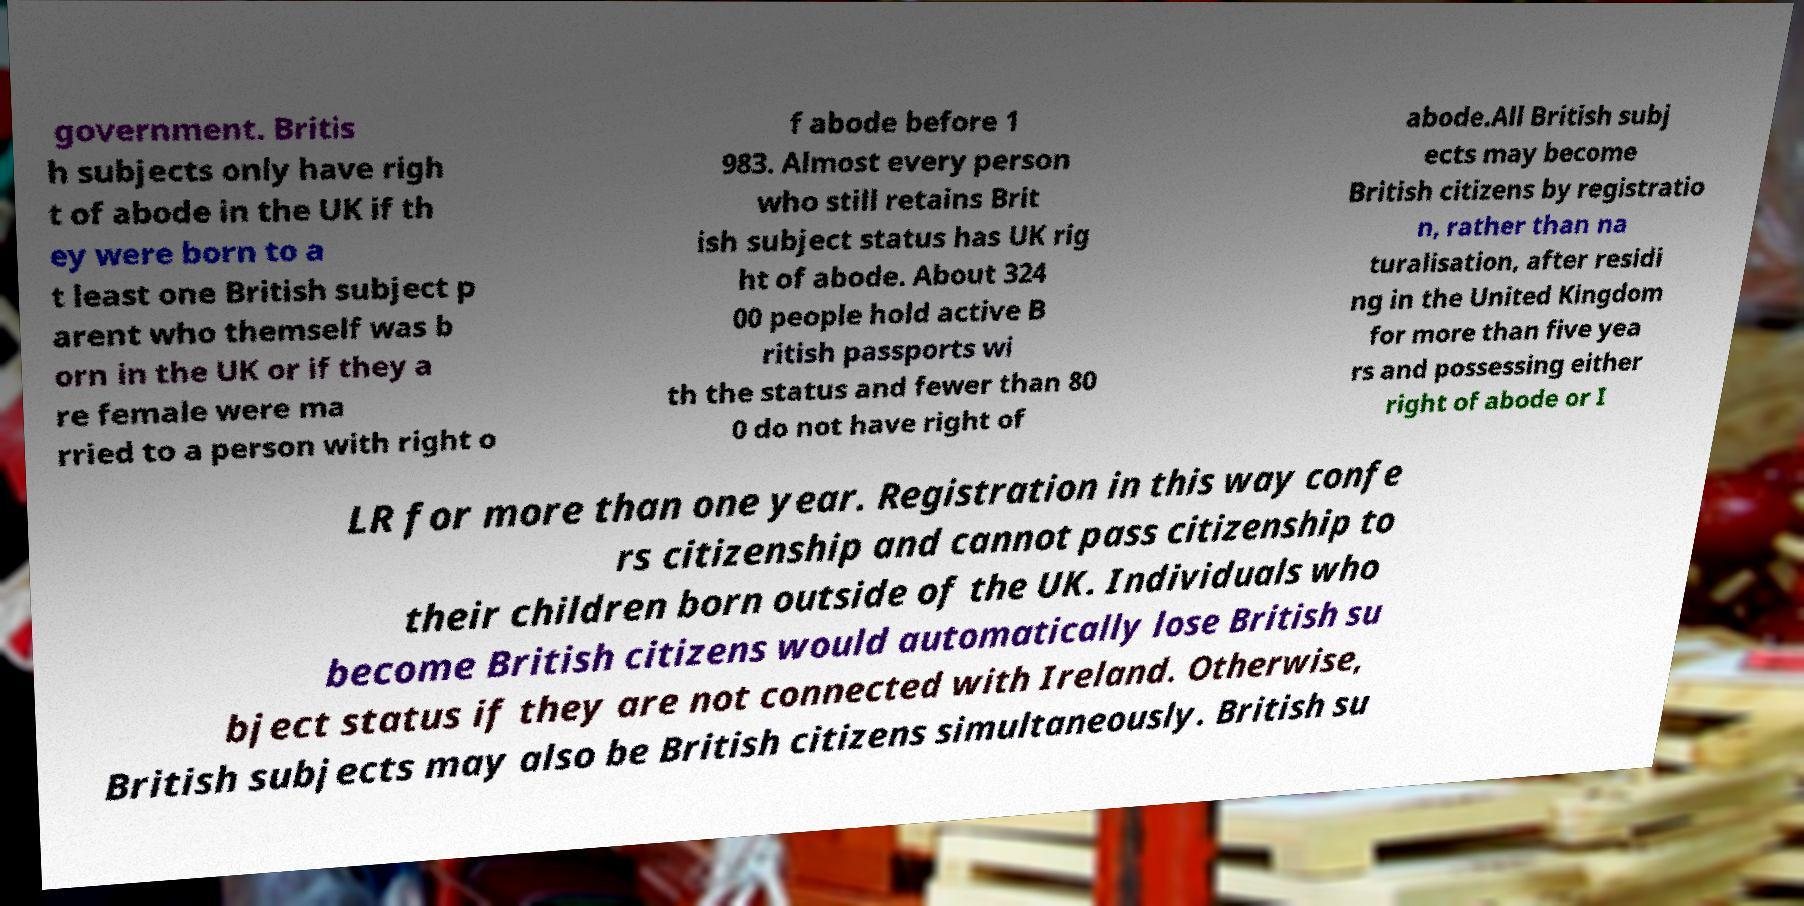What messages or text are displayed in this image? I need them in a readable, typed format. government. Britis h subjects only have righ t of abode in the UK if th ey were born to a t least one British subject p arent who themself was b orn in the UK or if they a re female were ma rried to a person with right o f abode before 1 983. Almost every person who still retains Brit ish subject status has UK rig ht of abode. About 324 00 people hold active B ritish passports wi th the status and fewer than 80 0 do not have right of abode.All British subj ects may become British citizens by registratio n, rather than na turalisation, after residi ng in the United Kingdom for more than five yea rs and possessing either right of abode or I LR for more than one year. Registration in this way confe rs citizenship and cannot pass citizenship to their children born outside of the UK. Individuals who become British citizens would automatically lose British su bject status if they are not connected with Ireland. Otherwise, British subjects may also be British citizens simultaneously. British su 